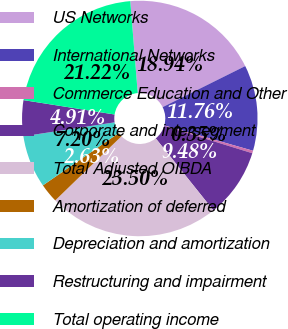Convert chart. <chart><loc_0><loc_0><loc_500><loc_500><pie_chart><fcel>US Networks<fcel>International Networks<fcel>Commerce Education and Other<fcel>Corporate and intersegment<fcel>Total Adjusted OIBDA<fcel>Amortization of deferred<fcel>Depreciation and amortization<fcel>Restructuring and impairment<fcel>Total operating income<nl><fcel>18.94%<fcel>11.76%<fcel>0.35%<fcel>9.48%<fcel>23.5%<fcel>2.63%<fcel>7.2%<fcel>4.91%<fcel>21.22%<nl></chart> 